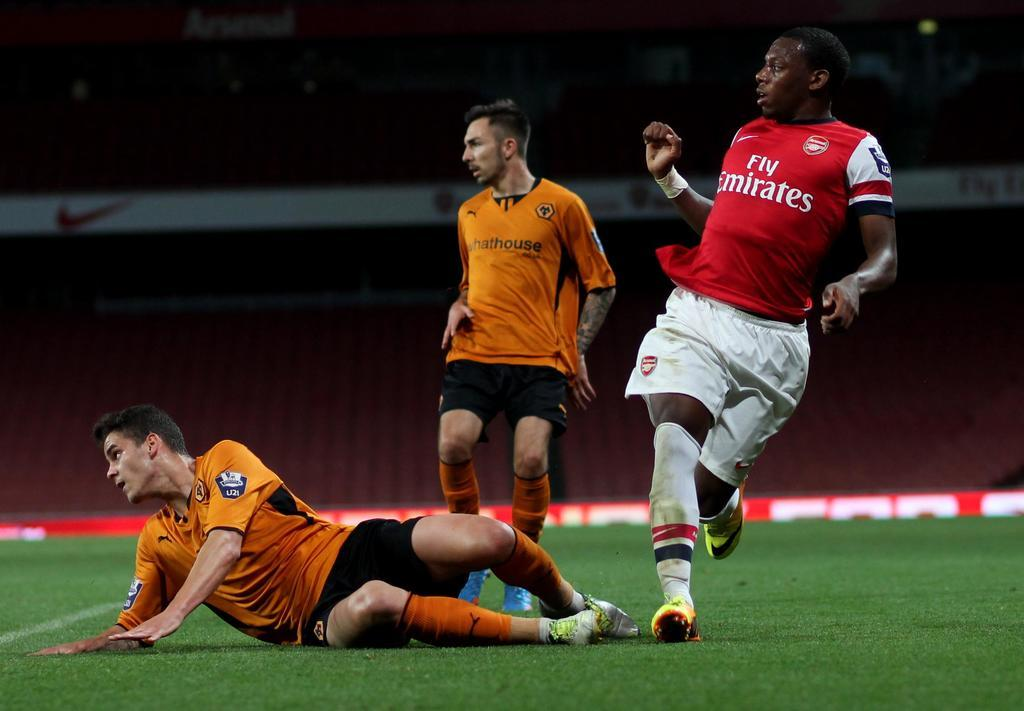<image>
Provide a brief description of the given image. A player in a red Fly Emirates jersey watches the soccer ball. 